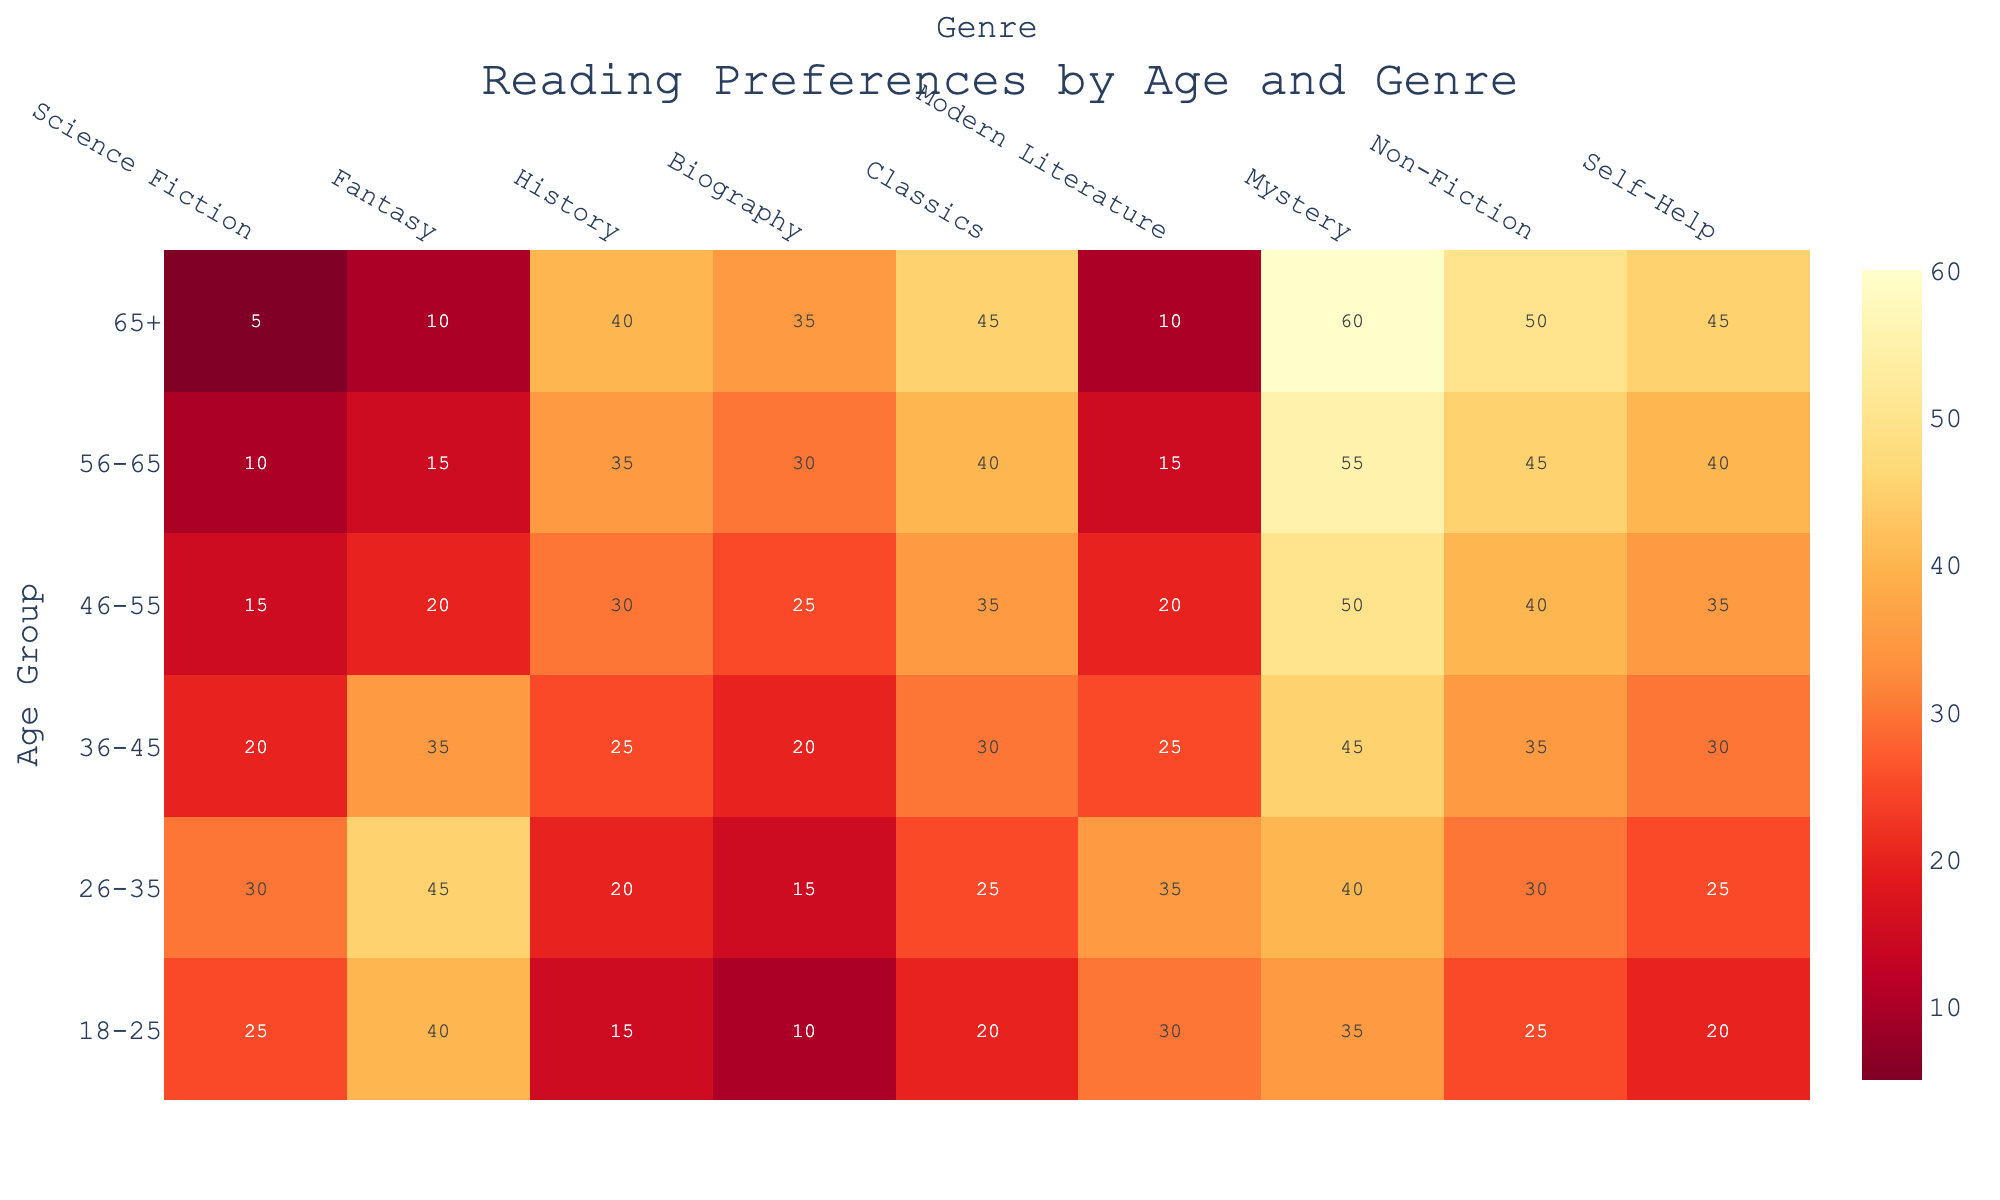What is the title of the figure? The title of the figure is displayed prominently at the top. It reads: "Reading Preferences by Age and Genre".
Answer: Reading Preferences by Age and Genre Which age group has the highest preference for Mystery? Find the cell with the highest value in the 'Mystery' column and check the corresponding 'Age Group' row. The highest value in 'Mystery' is 60, which corresponds to the age group '65+'.
Answer: 65+ How many genres are being compared in the heatmap? Count the number of genres listed on the x-axis. There are nine genres: Science Fiction, Fantasy, History, Biography, Classics, Modern Literature, Mystery, Non-Fiction, and Self-Help.
Answer: 9 What is the color scale used in the heatmap? The color scale is displayed in a gradient style on the heatmap. It goes from a lighter yellow to a darker red, indicating the 'YlOrRd' color scale.
Answer: YlOrRd Which age group has the least preference for Science Fiction? Find the cell with the smallest value in the 'Science Fiction' column and check the corresponding 'Age Group' row. The smallest value in 'Science Fiction' is 5, which corresponds to the age group '65+'.
Answer: 65+ Between the age groups 26-35 and 46-55, which one favors Non-Fiction more? Compare the values in the 'Non-Fiction' column for age groups 26-35 and 46-55. The value for 26-35 is 30, and for 46-55, it's 40. Hence, 46-55 favors Non-Fiction more.
Answer: 46-55 What is the average preference for Classics among all age groups? Sum the values in the 'Classics' column and then divide by the number of age groups (6). The sum is 20+25+30+35+40+45 = 195, and the average is 195/6 = 32.5.
Answer: 32.5 Which genre shows a linear increase in preference with age? Identify the genre where the values consistently increase as the age group increases. By examining the heatmap, 'Non-Fiction' shows a linear increase: 25, 30, 35, 40, 45, 50.
Answer: Non-Fiction What is the total preference count for Modern Literature in the age groups 18-25 and 36-45 combined? Add the values for Modern Literature for both age groups. The value for 18-25 is 30 and for 36-45 is 25, so the total is 30 + 25 = 55.
Answer: 55 How does the preference for Biography change with age? Analyze the trend in the 'Biography' column across different age groups. The values increase with age: 10, 15, 20, 25, 30, 35. This indicates a gradual increase in preference as age increases.
Answer: Gradual increase 